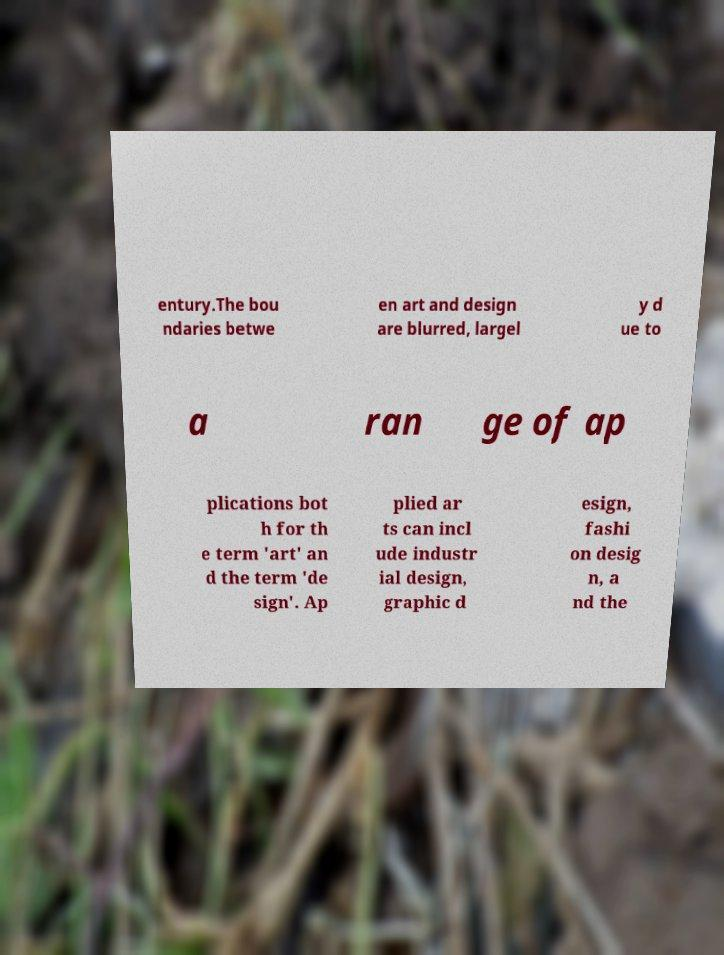Could you assist in decoding the text presented in this image and type it out clearly? entury.The bou ndaries betwe en art and design are blurred, largel y d ue to a ran ge of ap plications bot h for th e term 'art' an d the term 'de sign'. Ap plied ar ts can incl ude industr ial design, graphic d esign, fashi on desig n, a nd the 